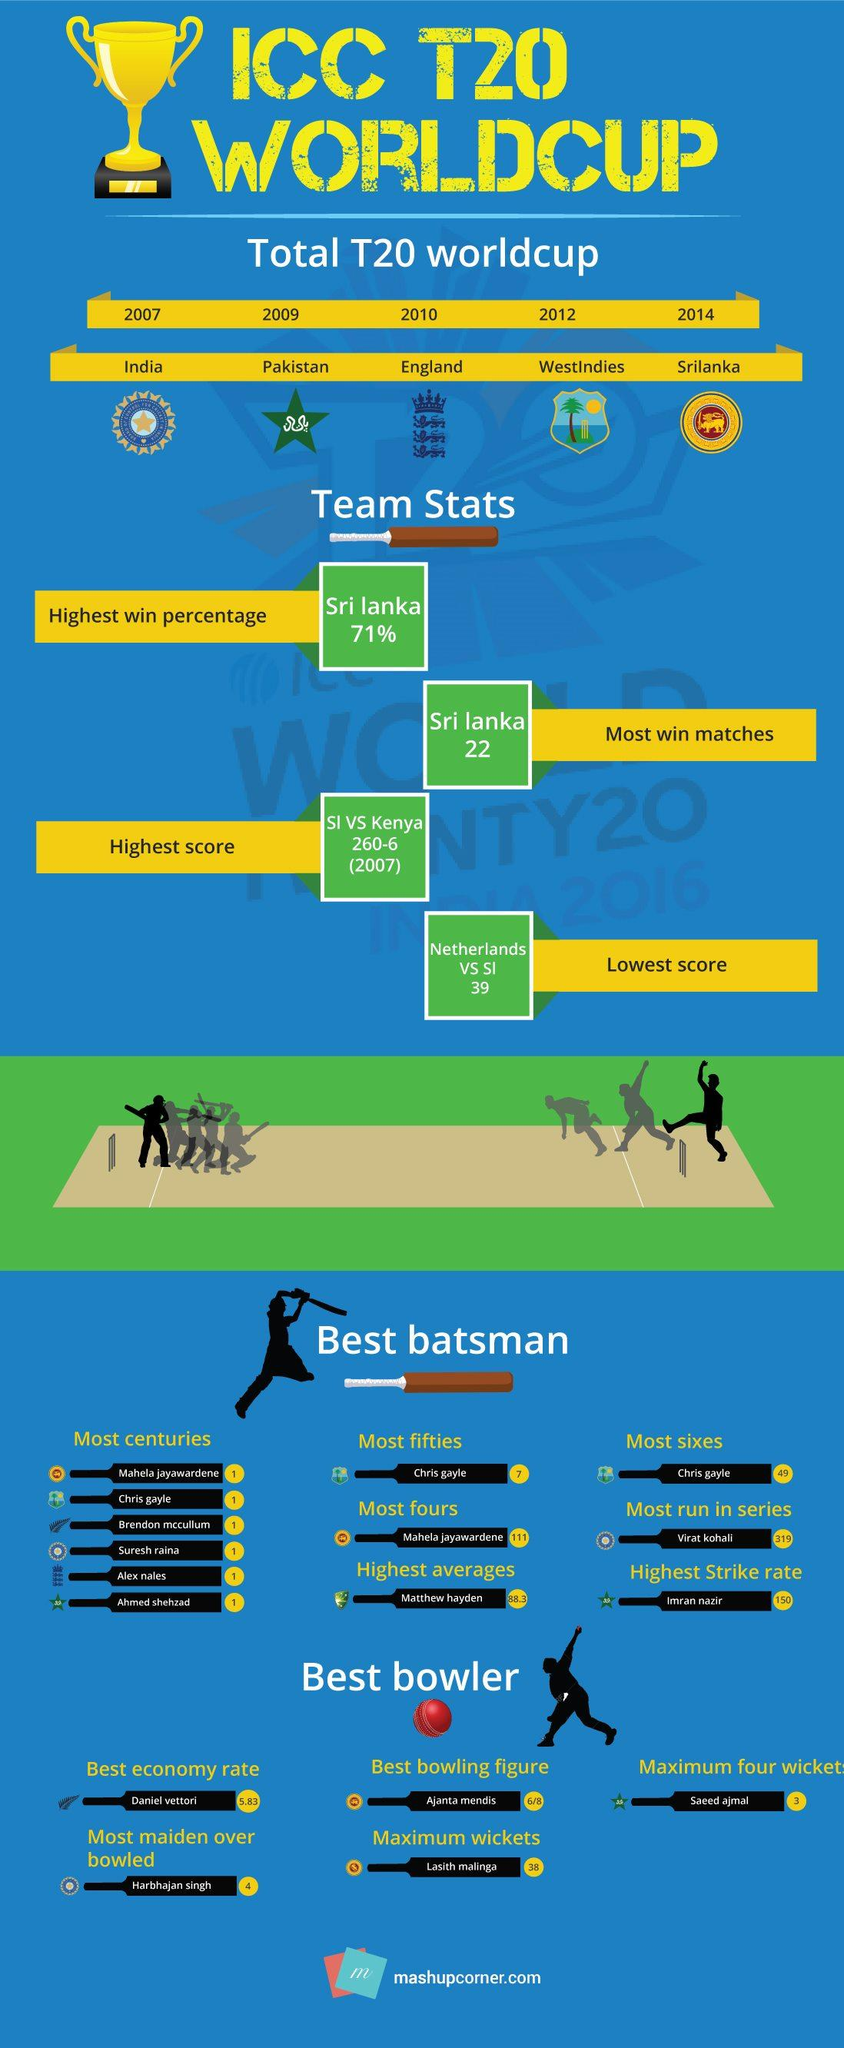Highlight a few significant elements in this photo. It is mentioned in this infographic that there are 5 T20 World Cups. Imran Nazir has the highest strike rate among all individuals, as declared by... England is the winner of the T20 World Cup 2010. West Indies is the winner of the T20 World Cup 2012. Matthew Hayden has the highest average among all individuals. 